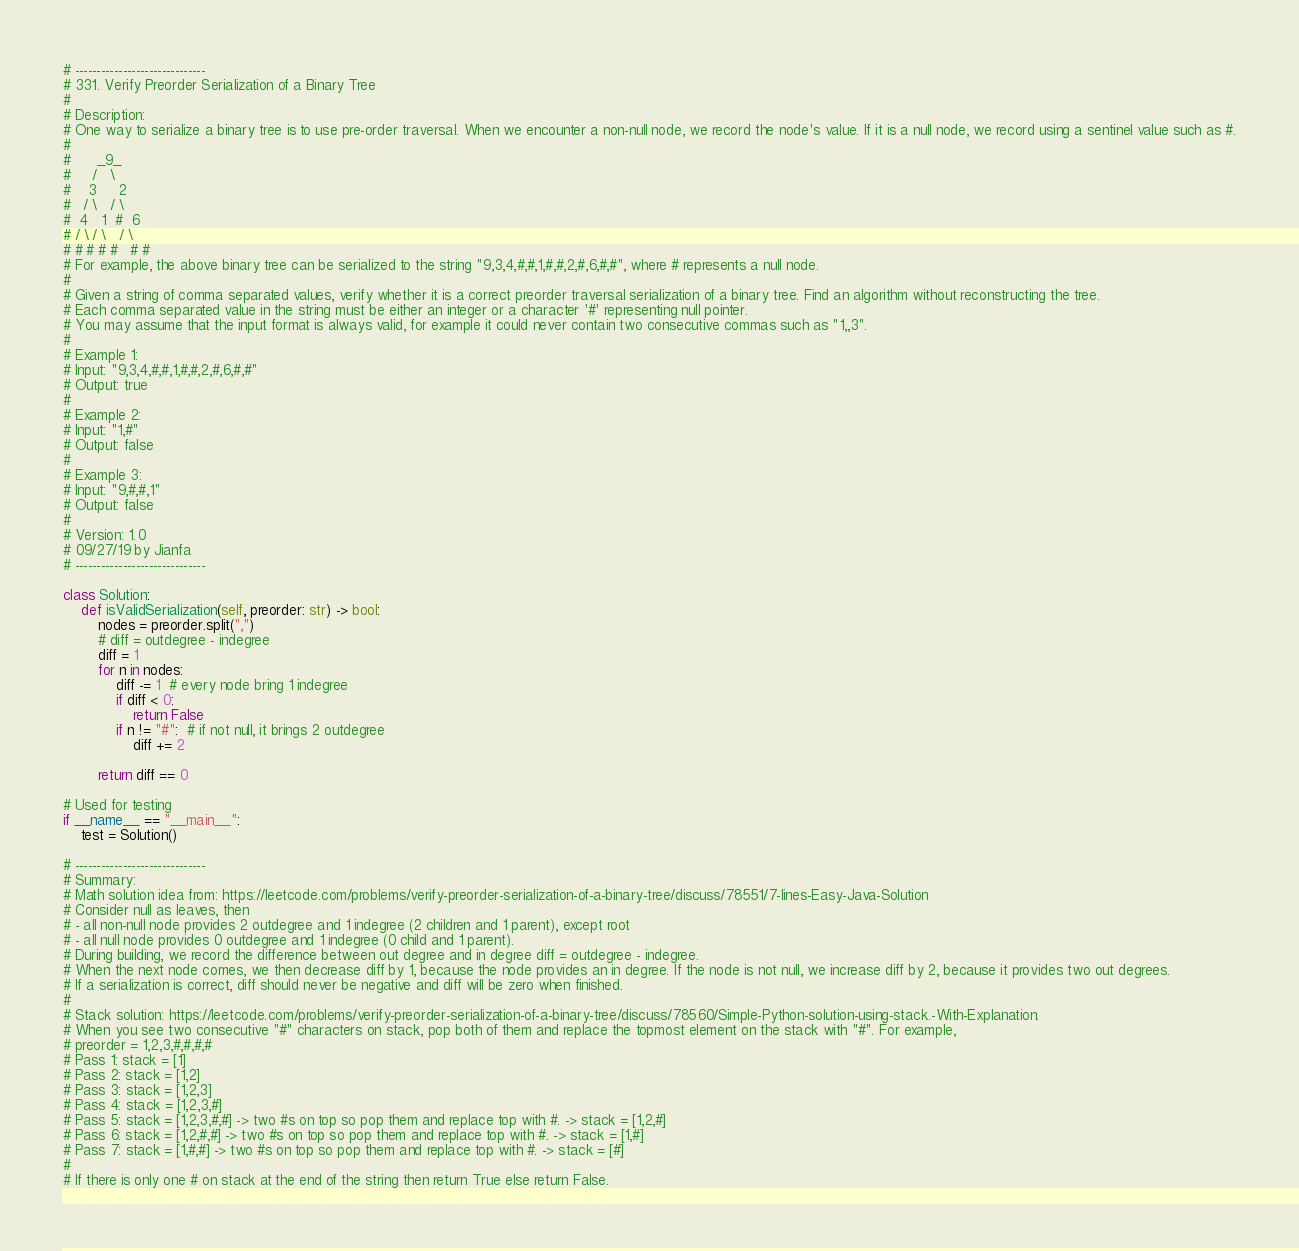<code> <loc_0><loc_0><loc_500><loc_500><_Python_># ------------------------------
# 331. Verify Preorder Serialization of a Binary Tree
# 
# Description:
# One way to serialize a binary tree is to use pre-order traversal. When we encounter a non-null node, we record the node's value. If it is a null node, we record using a sentinel value such as #.
# 
#      _9_
#     /   \
#    3     2
#   / \   / \
#  4   1  #  6
# / \ / \   / \
# # # # #   # #
# For example, the above binary tree can be serialized to the string "9,3,4,#,#,1,#,#,2,#,6,#,#", where # represents a null node.
# 
# Given a string of comma separated values, verify whether it is a correct preorder traversal serialization of a binary tree. Find an algorithm without reconstructing the tree.
# Each comma separated value in the string must be either an integer or a character '#' representing null pointer.
# You may assume that the input format is always valid, for example it could never contain two consecutive commas such as "1,,3".
# 
# Example 1:
# Input: "9,3,4,#,#,1,#,#,2,#,6,#,#"
# Output: true
# 
# Example 2:
# Input: "1,#"
# Output: false
# 
# Example 3:
# Input: "9,#,#,1"
# Output: false
# 
# Version: 1.0
# 09/27/19 by Jianfa
# ------------------------------

class Solution:
    def isValidSerialization(self, preorder: str) -> bool:
        nodes = preorder.split(",")
        # diff = outdegree - indegree
        diff = 1
        for n in nodes:
            diff -= 1  # every node bring 1 indegree
            if diff < 0:
                return False
            if n != "#":  # if not null, it brings 2 outdegree
                diff += 2

        return diff == 0

# Used for testing
if __name__ == "__main__":
    test = Solution()

# ------------------------------
# Summary:
# Math solution idea from: https://leetcode.com/problems/verify-preorder-serialization-of-a-binary-tree/discuss/78551/7-lines-Easy-Java-Solution
# Consider null as leaves, then
# - all non-null node provides 2 outdegree and 1 indegree (2 children and 1 parent), except root
# - all null node provides 0 outdegree and 1 indegree (0 child and 1 parent).
# During building, we record the difference between out degree and in degree diff = outdegree - indegree.
# When the next node comes, we then decrease diff by 1, because the node provides an in degree. If the node is not null, we increase diff by 2, because it provides two out degrees. 
# If a serialization is correct, diff should never be negative and diff will be zero when finished.
# 
# Stack solution: https://leetcode.com/problems/verify-preorder-serialization-of-a-binary-tree/discuss/78560/Simple-Python-solution-using-stack.-With-Explanation.
# When you see two consecutive "#" characters on stack, pop both of them and replace the topmost element on the stack with "#". For example,
# preorder = 1,2,3,#,#,#,#
# Pass 1: stack = [1]
# Pass 2: stack = [1,2]
# Pass 3: stack = [1,2,3]
# Pass 4: stack = [1,2,3,#]
# Pass 5: stack = [1,2,3,#,#] -> two #s on top so pop them and replace top with #. -> stack = [1,2,#]
# Pass 6: stack = [1,2,#,#] -> two #s on top so pop them and replace top with #. -> stack = [1,#]
# Pass 7: stack = [1,#,#] -> two #s on top so pop them and replace top with #. -> stack = [#]
# 
# If there is only one # on stack at the end of the string then return True else return False.

</code> 